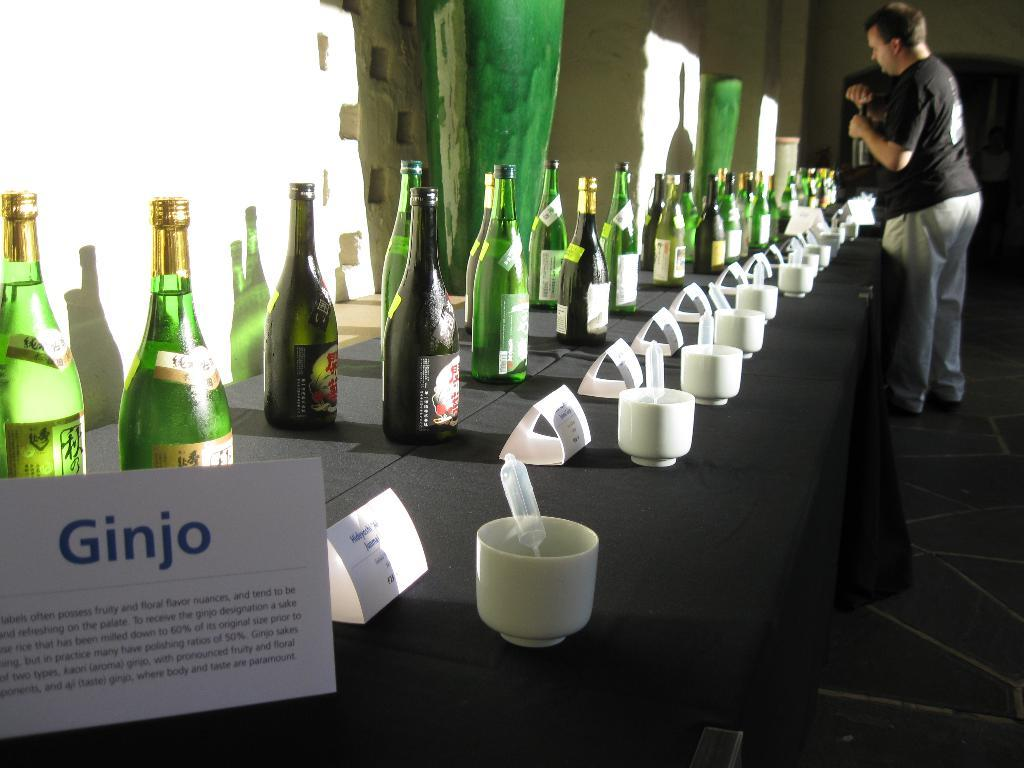What is the color of the wall in the image? The wall in the image is white. What objects are on the table in the image? There are bottles and cups on the table in the image. Who is present in the image? There is a man standing in the image. Where is the man standing in the image? The man is standing on the floor in the image. What type of observation can be made about the man's lips in the image? There is no mention of the man's lips in the image, so no observation can be made about them. 